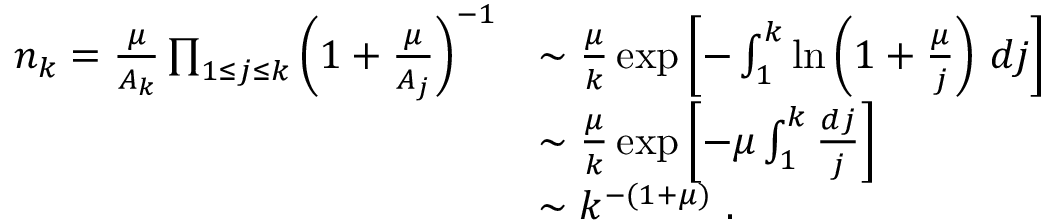Convert formula to latex. <formula><loc_0><loc_0><loc_500><loc_500>\begin{array} { r l } { n _ { k } = \frac { \mu } { A _ { k } } \prod _ { 1 \leq j \leq k } \left ( 1 + \frac { \mu } { A _ { j } } \right ) ^ { - 1 } } & { \sim \frac { \mu } { k } \exp \left [ - \int _ { 1 } ^ { k } \ln \left ( 1 + \frac { \mu } { j } \right ) \, d j \right ] } \\ & { \sim \frac { \mu } { k } \exp \left [ - \mu \int _ { 1 } ^ { k } \frac { d j } { j } \right ] } \\ & { \sim k ^ { - ( 1 + \mu ) } . } \end{array}</formula> 